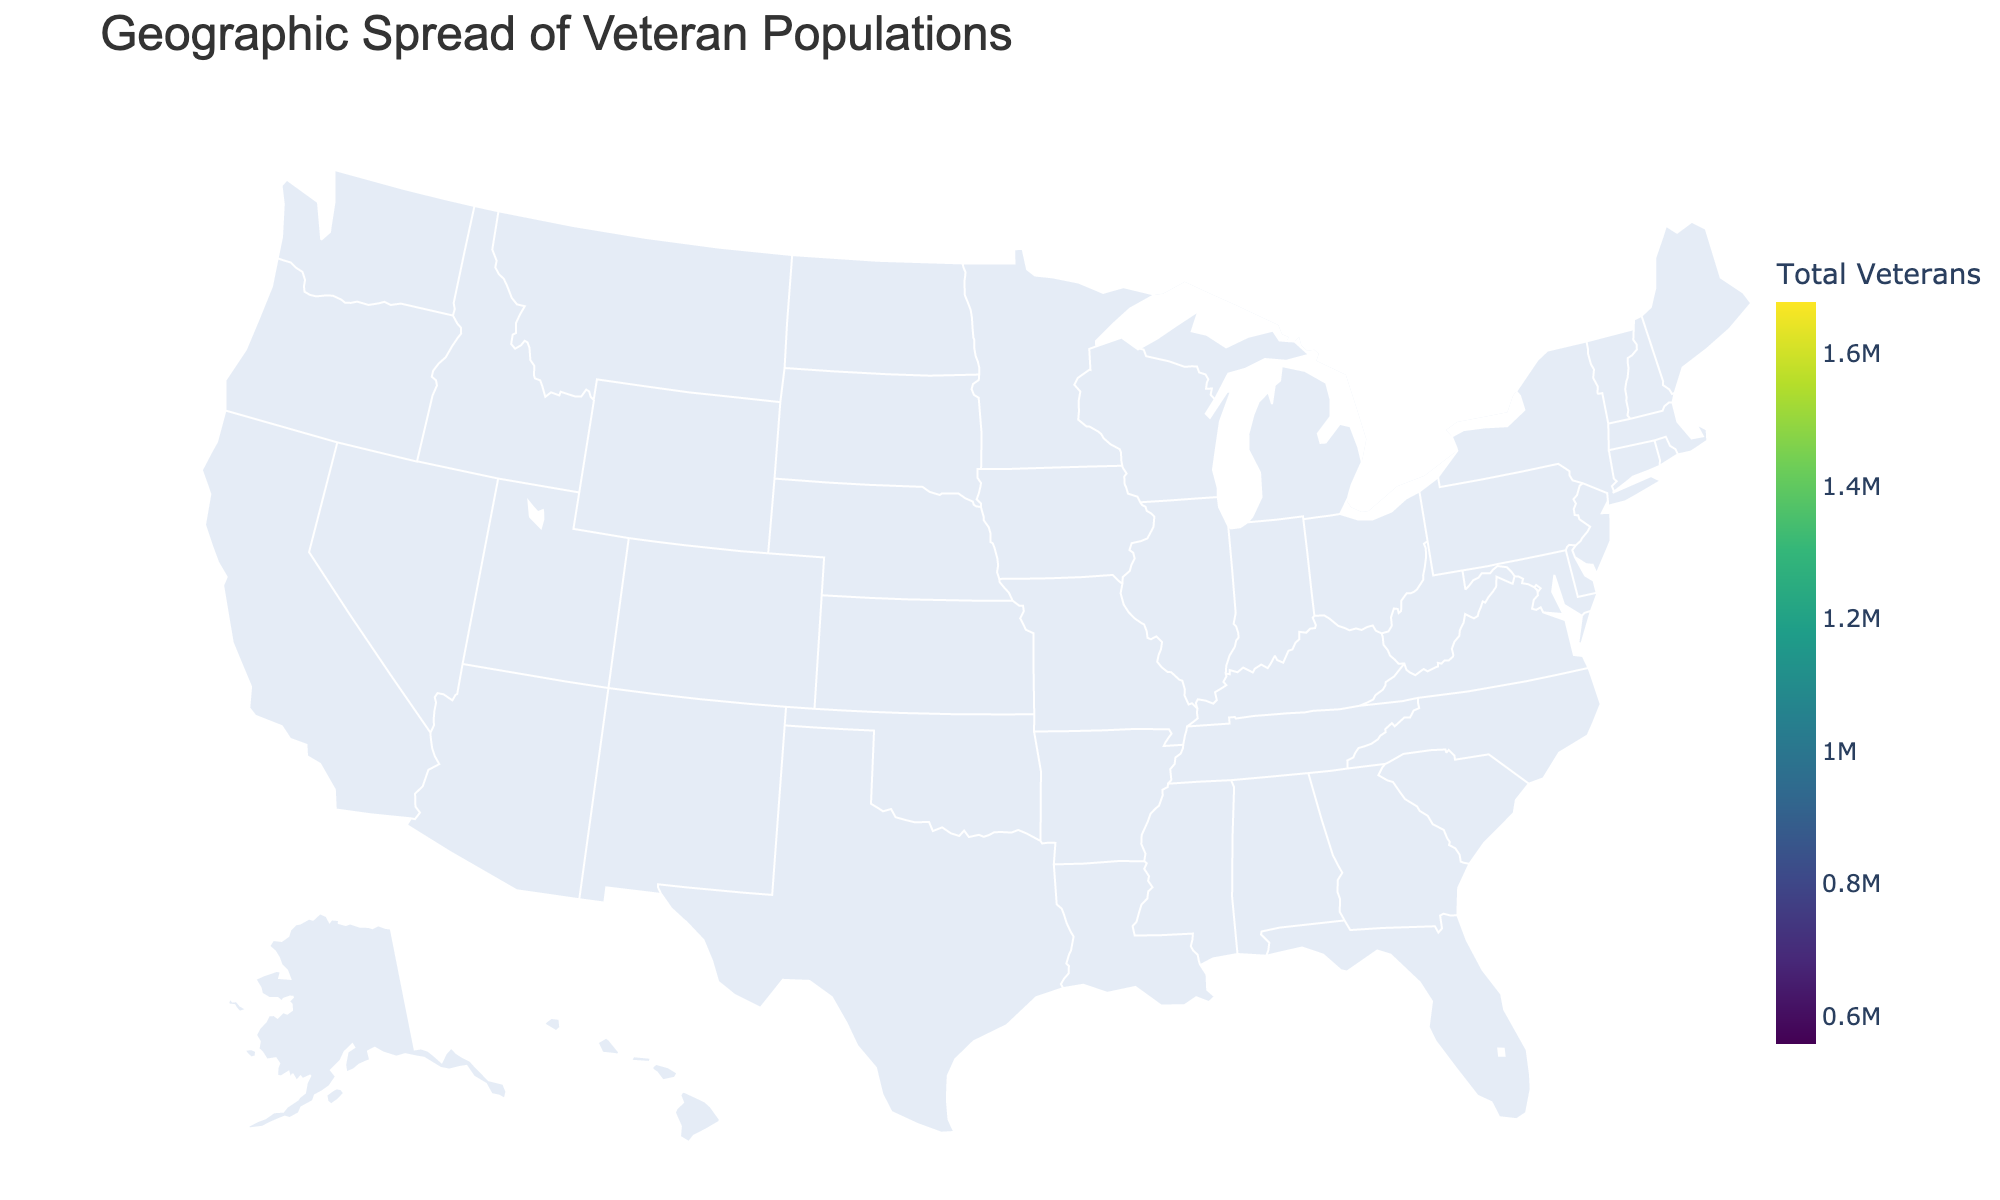What is the title of the figure? The title is usually placed at the top center of the figure. It provides an overall description of what the figure is depicting. In this case, the title is "Geographic Spread of Veteran Populations."
Answer: Geographic Spread of Veteran Populations Which state has the highest number of total veterans? By looking at the color intensity on the map and checking the color bar, we can see that California and Texas have the highest values. The text annotations also confirm that California (1,680,000) has slightly more veterans than Texas (1,620,000).
Answer: California What is the total number of Post 9/11 Era veterans in Virginia? Hover over Virginia on the map to see additional information. The hover data will show the numbers for different service eras, including the Post 9/11 Era.
Answer: 180,000 Which state has fewer Vietnam Era veterans, Ohio or New York? By comparing the data from the hover information or the text annotation on the figure, we can see that Ohio has 260,000 Vietnam Era veterans whereas New York has 240,000. Therefore, New York has fewer Vietnam Era veterans.
Answer: New York Sum the number of veterans from the Army and Navy in North Carolina. Check the hover details or text annotations over North Carolina and add the number of Army veterans (320,000) and Navy veterans (140,000). So, 320,000 + 140,000 = 460,000.
Answer: 460,000 Which state has more veterans from the Air Force, Florida or Georgia? By examining the hover data or text annotations, we see that Florida has 340,000 Air Force veterans whereas Georgia has 160,000. Therefore, Florida has more Air Force veterans.
Answer: Florida What is the range of total veterans among the states presented in the figure? The range is calculated by subtracting the smallest value from the largest value. California has the highest at 1,680,000 and Washington has the lowest at 560,000. So, 1,680,000 - 560,000 = 1,120,000.
Answer: 1,120,000 Which state has the least number of Marines veterans? By checking the hover data or text annotations for each state, Washington has the lowest number of Marines veterans with 40,000.
Answer: Washington 